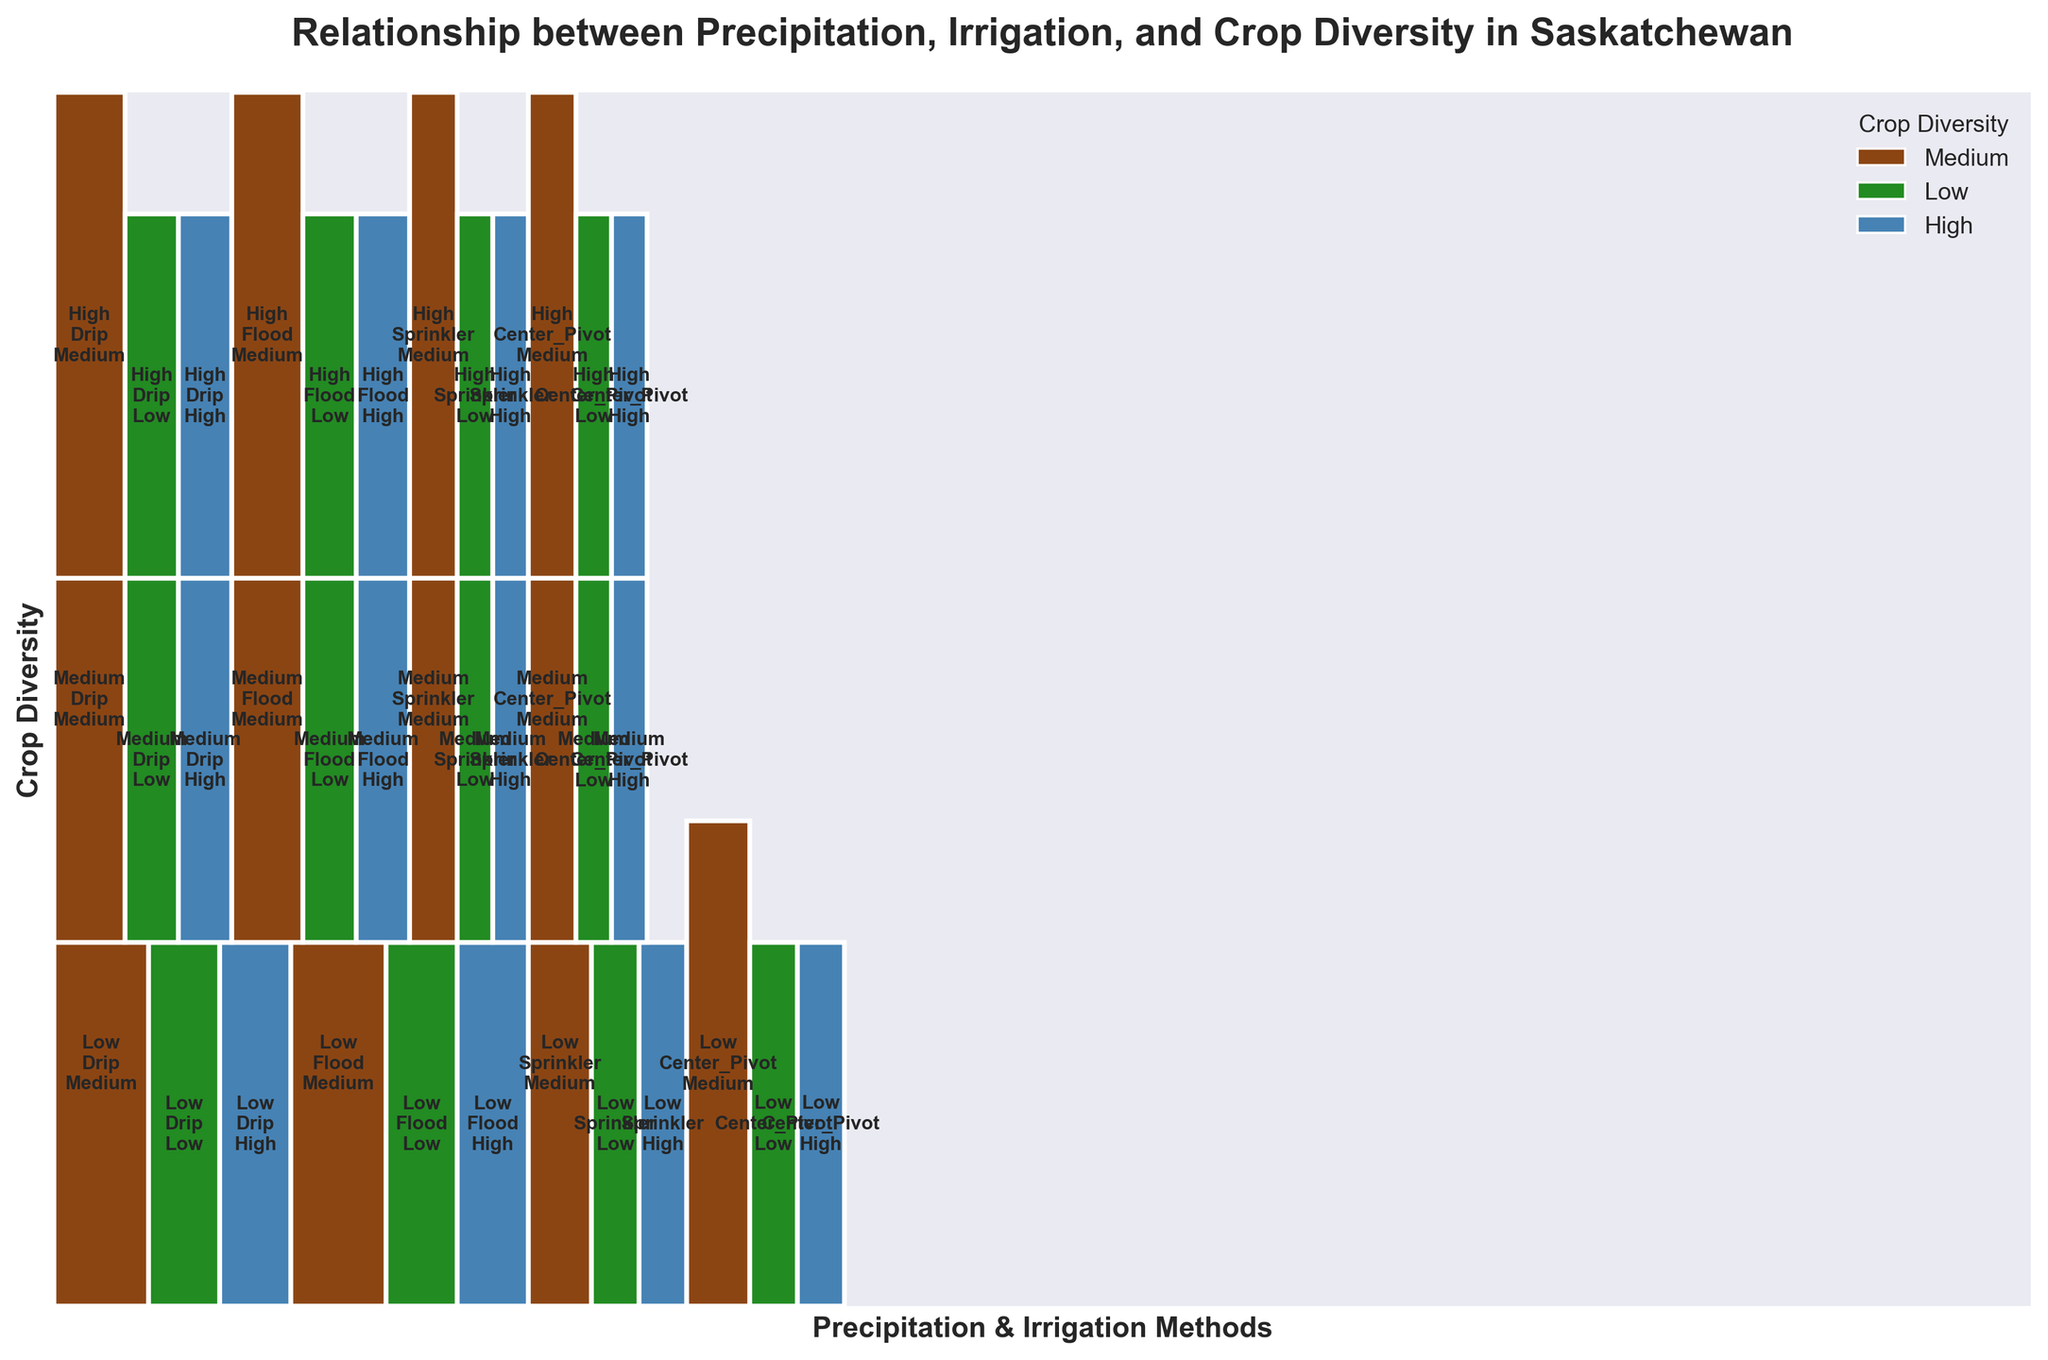What is the title of the plot? The title is usually found at the top of the plot. For this figure, we look at the top center and see it displayed there.
Answer: Relationship between Precipitation, Irrigation, and Crop Diversity in Saskatchewan How many crop diversity levels are represented in the plot? We look at the legend in the upper right corner of the plot, which shows the different crop diversity levels indicated by color.
Answer: 3 Which region has a combination of high precipitation, center-pivot irrigation, and high crop diversity? In the plot, search for the section labeled "High" under precipitation, combined with "Center_Pivot" under irrigation, and "High" under crop diversity. The corresponding label will show the region.
Answer: Prince Albert Is there any region with low precipitation using drip irrigation that has medium crop diversity? Find the sections labeled with combinations of low precipitation and drip irrigation, then check if any of them show medium crop diversity.
Answer: Estevan Which has a higher visual representation in this plot, low or high precipitation? Compare the total area covered by rectangles labeled "Low" with the area covered by those labeled "High." This allows us to infer which one is larger.
Answer: Low What are the irrigation methods used for regions with medium precipitation and high crop diversity? Locate the sections labeled with medium precipitation and high crop diversity, then identify the irrigation methods listed for those sections.
Answer: Flood, Center_Pivot How does crop diversity differ between high and medium precipitation regions? Compare the crop diversity levels of regions labeled with high precipitation against those labeled with medium precipitation. We look for patterns in crop diversity within these particular regions.
Answer: High precipitation generally shows medium to high crop diversity, while medium precipitation shows varied crop diversity (low to high) Are there any regions with high precipitation and low crop diversity? Search the high precipitation sections and check for any rectangles labeled with low crop diversity.
Answer: North Battleford Which combination of factors (precipitation, irrigation, crop diversity) appears most frequently? Determine frequency by noting the number of times each unique combination is represented. Count the occurrences of each set of labels to find the most frequent combination.
Answer: Low precipitation, drip irrigation, and medium crop diversity How many regions combine medium precipitation with low crop diversity, irrespective of irrigation method? Look at all sections marked with medium precipitation and identify how many of these also show low crop diversity. Count the occurrences regardless of the irrigation method.
Answer: 1 